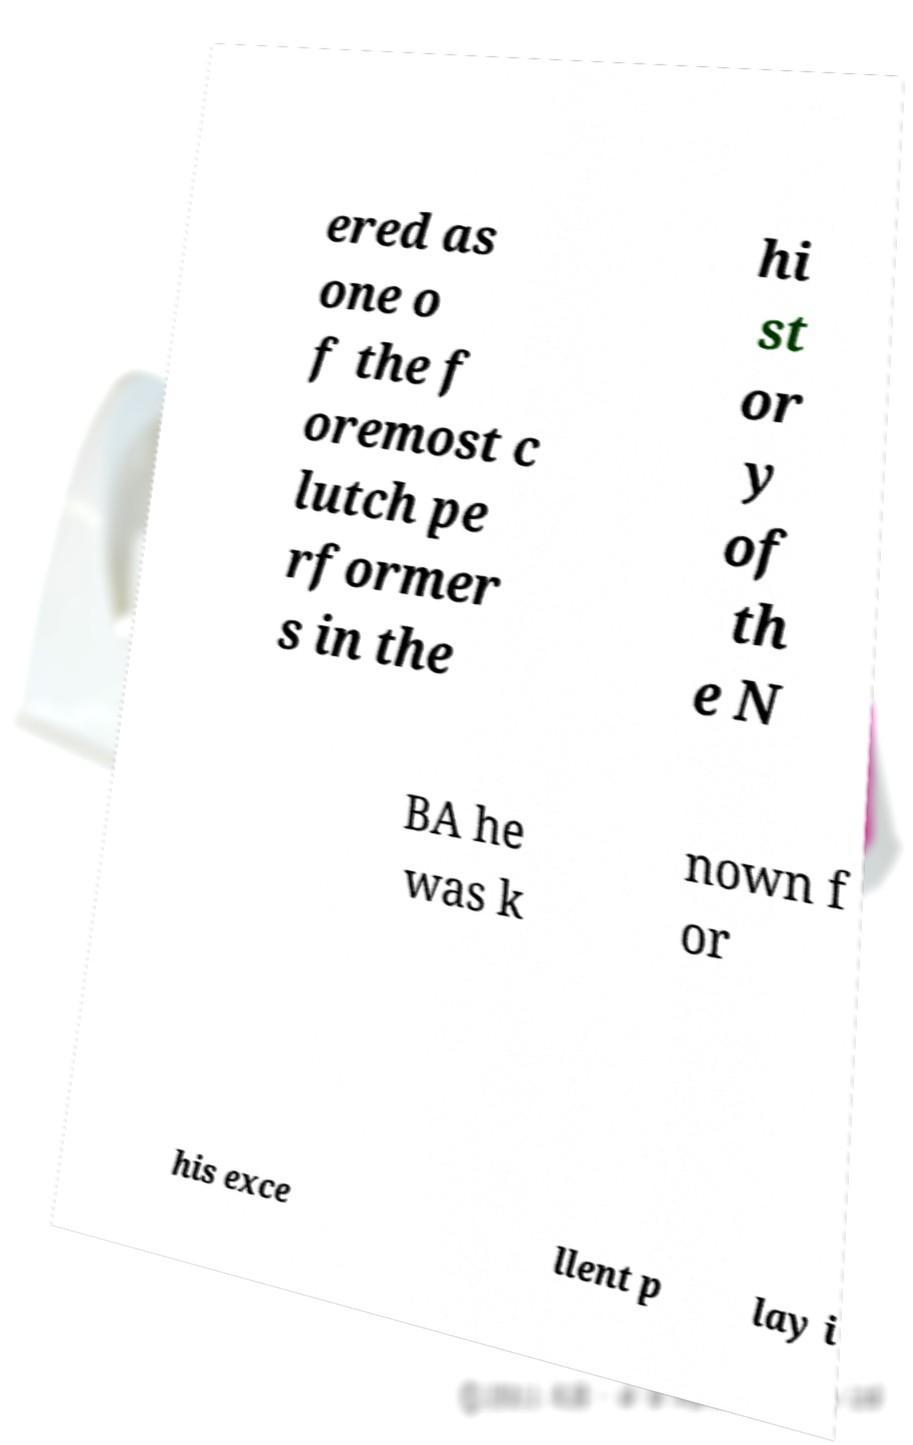Could you extract and type out the text from this image? ered as one o f the f oremost c lutch pe rformer s in the hi st or y of th e N BA he was k nown f or his exce llent p lay i 